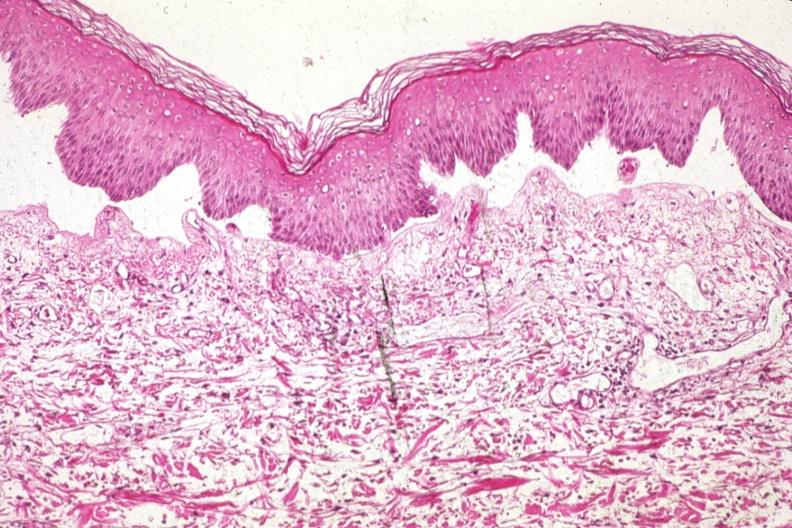where is this?
Answer the question using a single word or phrase. Skin 